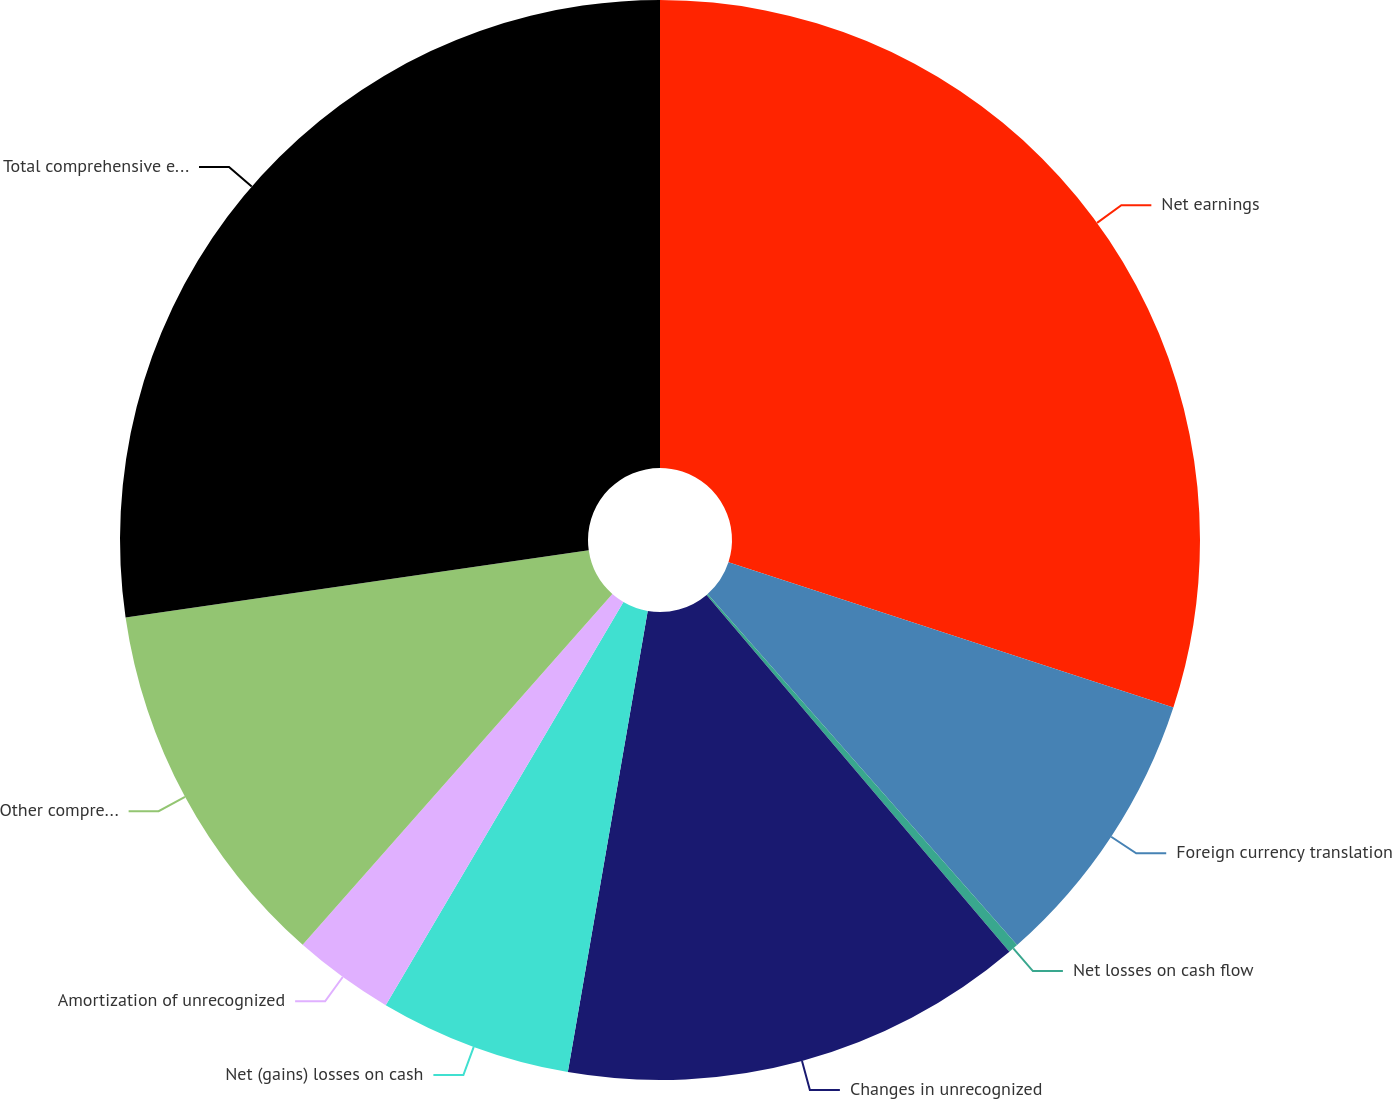Convert chart to OTSL. <chart><loc_0><loc_0><loc_500><loc_500><pie_chart><fcel>Net earnings<fcel>Foreign currency translation<fcel>Net losses on cash flow<fcel>Changes in unrecognized<fcel>Net (gains) losses on cash<fcel>Amortization of unrecognized<fcel>Other comprehensive earnings<fcel>Total comprehensive earnings<nl><fcel>30.02%<fcel>8.48%<fcel>0.3%<fcel>13.93%<fcel>5.75%<fcel>3.03%<fcel>11.2%<fcel>27.29%<nl></chart> 